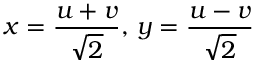Convert formula to latex. <formula><loc_0><loc_0><loc_500><loc_500>x = { \frac { u + v } { \sqrt { 2 } } } , \, y = { \frac { u - v } { \sqrt { 2 } } }</formula> 